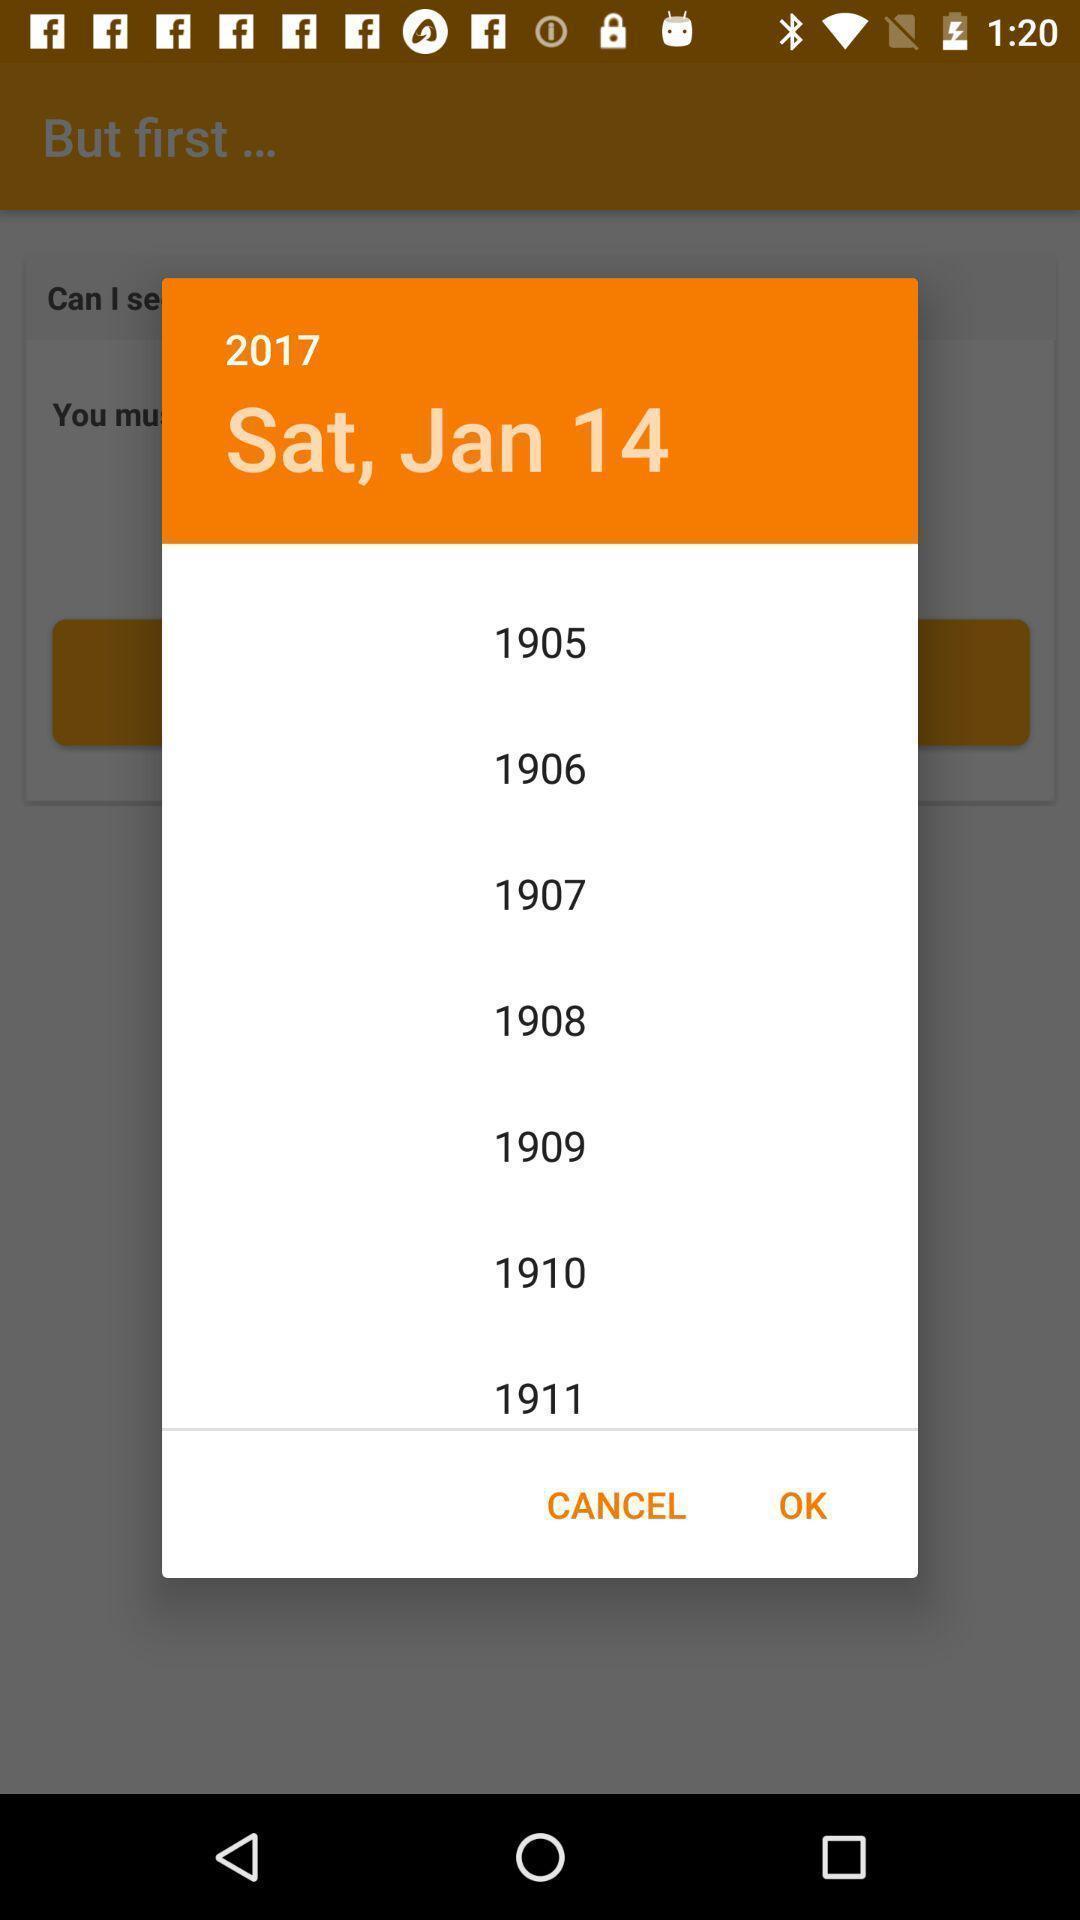What details can you identify in this image? Popup showing date and years to select. 